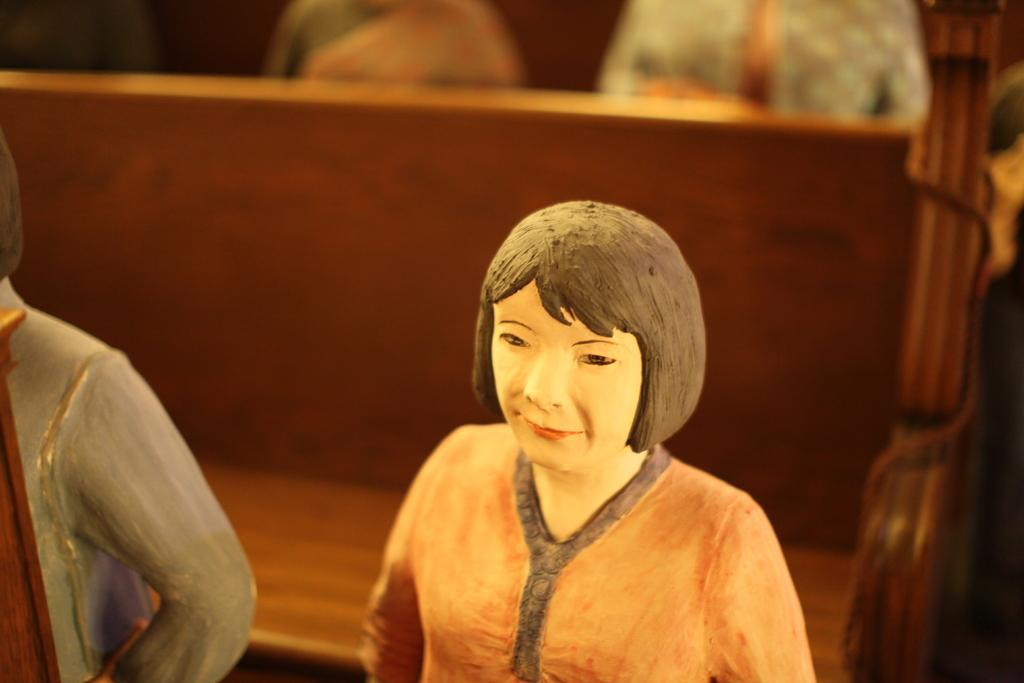What type of objects are the statues in the image? The statues in the image are of people. What type of seating is present in the image? There is a bench in the image. What type of tin can be seen in the image? There is no tin present in the image. What type of dirt can be seen on the statues in the image? There is no dirt visible on the statues in the image. What type of clam is located near the bench in the image? There is no clam present in the image. 